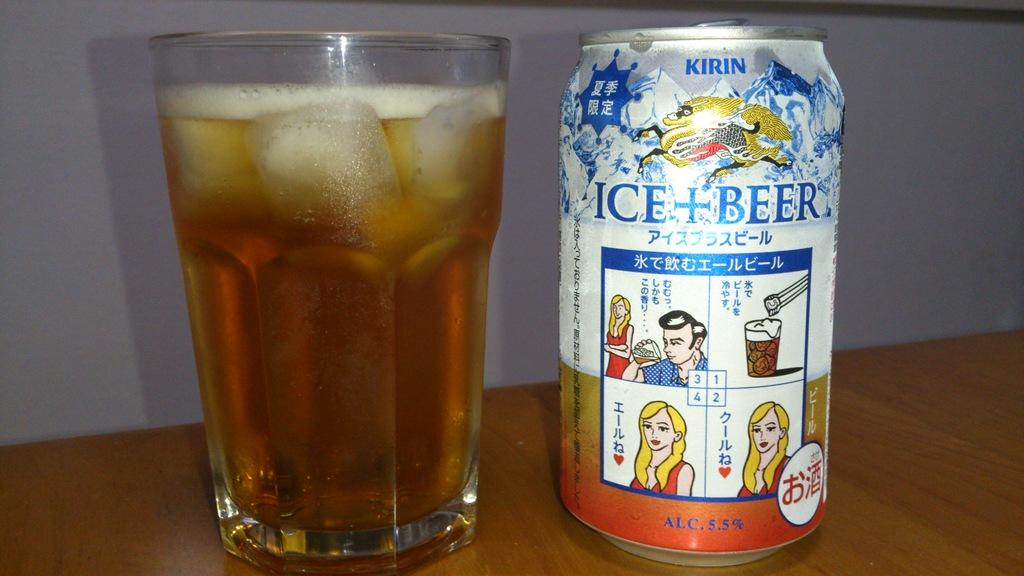<image>
Present a compact description of the photo's key features. A can of Kirin brand beer that says Ice + Beer. 